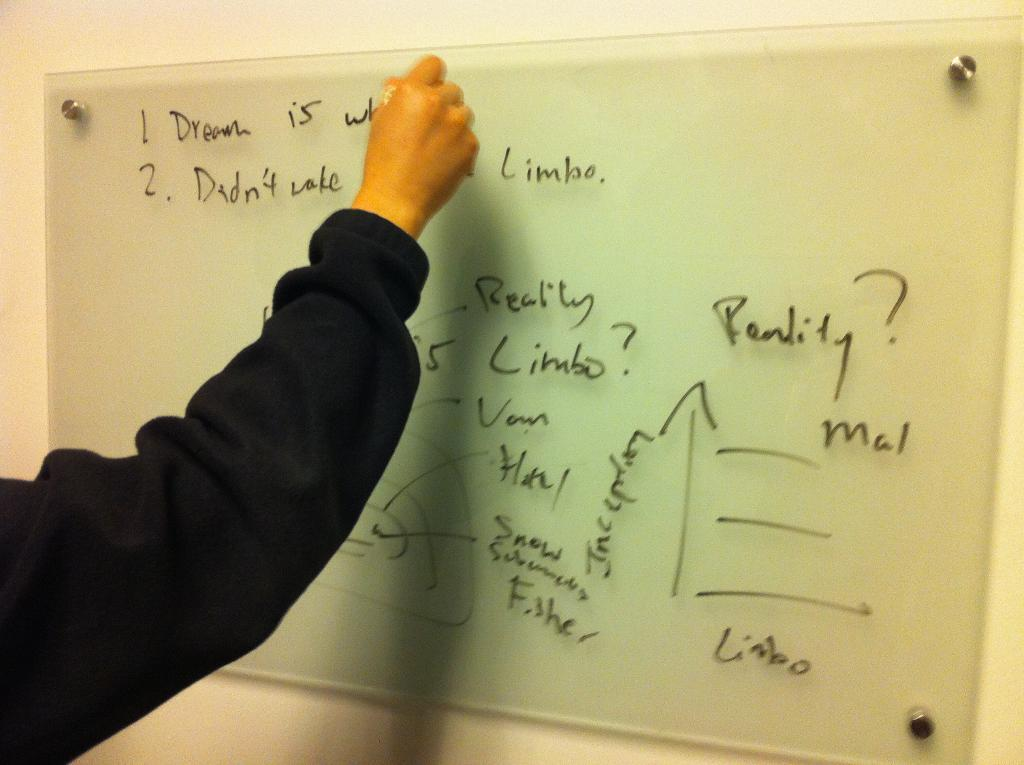<image>
Offer a succinct explanation of the picture presented. A hand is writing on a board, next to the word limbo. 